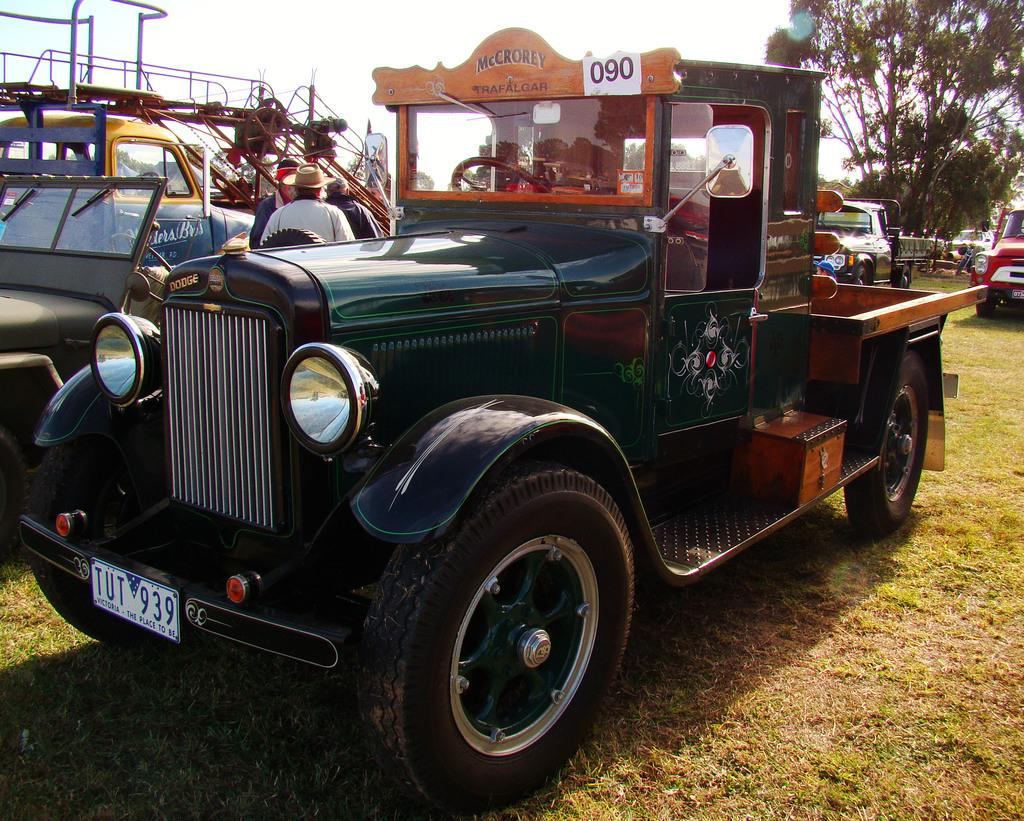What type of objects are on the ground in the image? There are vehicles on the ground in the image. What type of natural environment is visible in the image? There is grass and trees visible in the image. Who or what else is present in the image? There are people present in the image. What can be seen in the background of the image? The sky is visible in the background of the image. What type of oil is being used to maintain the grass in the image? There is no mention of oil or any maintenance activity related to the grass in the image. Can you see a tray being used by any of the people in the image? There is no tray visible in the image. 